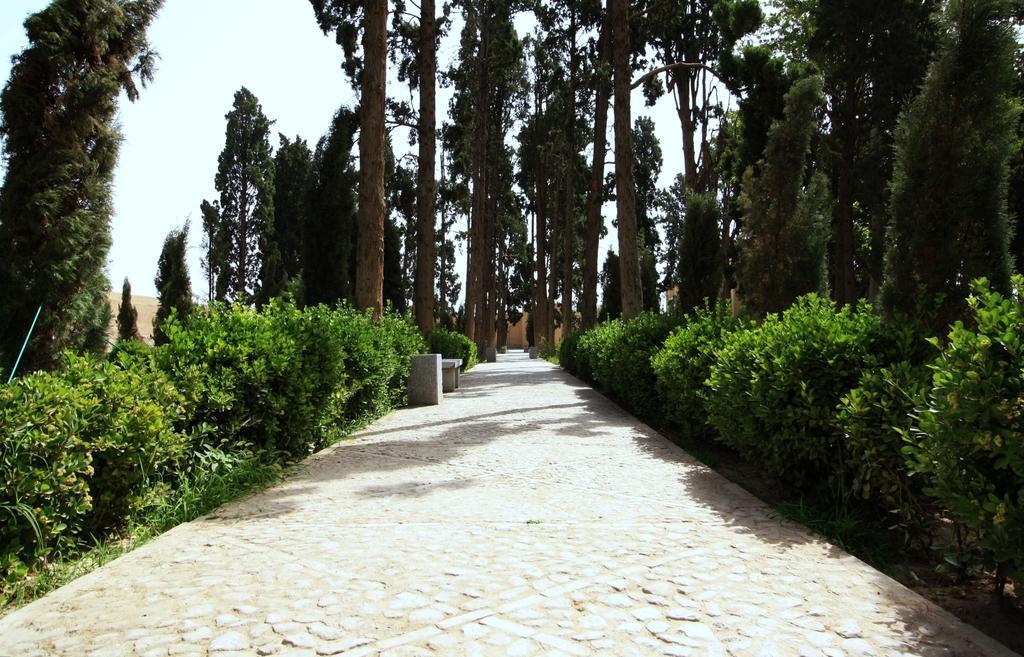Can you describe this image briefly? In this image I can see the road. To the side of the road there are many plants and trees which are in green color. In the back I can see the sky. 